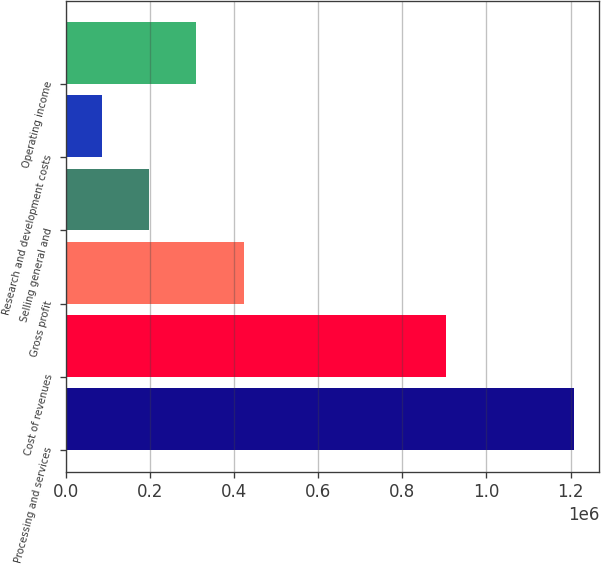<chart> <loc_0><loc_0><loc_500><loc_500><bar_chart><fcel>Processing and services<fcel>Cost of revenues<fcel>Gross profit<fcel>Selling general and<fcel>Research and development costs<fcel>Operating income<nl><fcel>1.20843e+06<fcel>904124<fcel>422520<fcel>197975<fcel>85702<fcel>310248<nl></chart> 